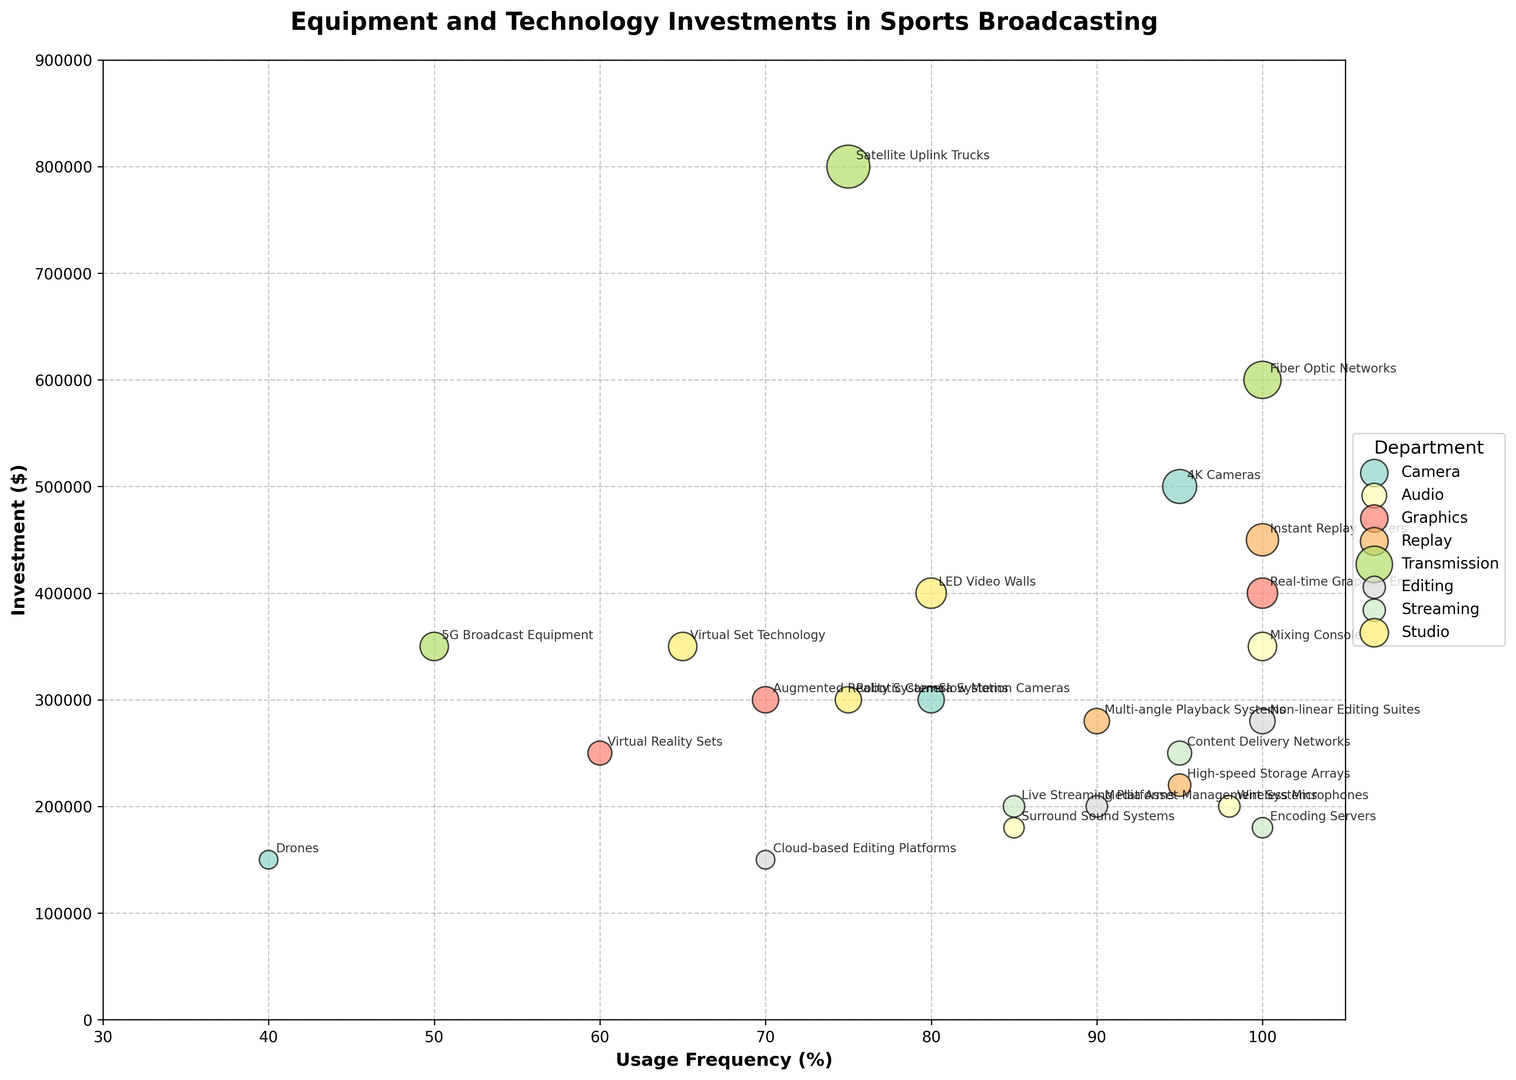Which department has the highest total investment in equipment? To determine the department with the highest total investment, sum up the individual investments for each department and compare them. Camera: $950,000, Audio: $730,000, Graphics: $950,000, Replay: $950,000, Transmission: $1,750,000, Editing: $630,000, Streaming: $630,000, Studio: $1,050,000. The Transmission department has the highest total investment of $1,750,000.
Answer: Transmission Which equipment has the lowest usage frequency, and which department does it belong to? Look at the usage frequency of all equipment and identify the one with the lowest percentage. The equipment with the lowest usage frequency is "Drones” at 40%, which belongs to the Camera department.
Answer: Drones, Camera Does the Graphics department's equipment generally have higher investment amounts than the Audio department's equipment? Compare the investment amounts of equipment in both departments. The Graphics department has investments of $400,000, $250,000, and $300,000, while the Audio department has investments of $200,000, $350,000, and $180,000. The average investment for Graphics is $316,666.67 and for Audio is $243,333.33. Thus, the Graphics department generally has higher investment amounts.
Answer: Yes What is the combined usage frequency of all equipment in the Editing department? Add up the usage frequencies of all equipment in the Editing department: Non-linear Editing Suites (100%), Cloud-based Editing Platforms (70%), and Media Asset Management Systems (90%). The combined usage frequency is 100% + 70% + 90% = 260%.
Answer: 260% Which department has the most frequently used equipment, and what is the equipment? Identify the equipment with the highest usage frequency across all departments. The highest usage frequency is 100%, which corresponds to Wireless Microphones (Audio), Mixing Consoles (Audio), Real-time Graphics Engines (Graphics), Instant Replay Servers (Replay), Fiber Optic Networks (Transmission), Non-linear Editing Suites (Editing), Encoding Servers (Streaming). The Audio department has the most frequently used equipment (Mixing Consoles), but since multiple departments also tie for the highest frequencies, all respective departments should be listed.
Answer: Audio, Graphics, Replay, Transmission, Editing, Streaming Which piece of equipment has the highest investment and what is its usage frequency? Find the equipment with the highest investment amount and note its usage frequency. The highest investment is $800,000 for Satellite Uplink Trucks with a usage frequency of 75%.
Answer: Satellite Uplink Trucks, 75% Is the average usage frequency of the equipment in the Streaming department higher or lower than the average usage frequency in the Replay department? Calculate the average usage frequency for both departments. Streaming: (100% + 95% + 85%) / 3 = 93.33%. Replay: (100% + 90% + 95%) / 3 = 95%. The average usage frequency in Streaming is lower than in Replay.
Answer: Lower 